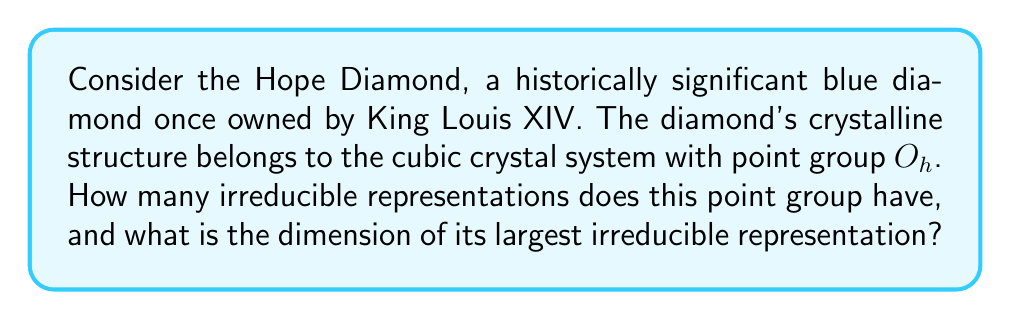Help me with this question. To solve this problem, we need to follow these steps:

1) First, recall that the point group $O_h$ is the full octahedral group, which is the symmetry group of a regular octahedron.

2) The order of the group $O_h$ is 48. This is because it contains 24 rotational symmetries and 24 rotoinversion symmetries.

3) For any finite group, the number of irreducible representations is equal to the number of conjugacy classes in the group. For $O_h$, there are 10 conjugacy classes.

4) To find the dimension of the largest irreducible representation, we can use the fact that the sum of the squares of the dimensions of all irreducible representations must equal the order of the group:

   $$\sum_{i=1}^{10} d_i^2 = 48$$

   where $d_i$ is the dimension of the $i$-th irreducible representation.

5) The dimensions of the irreducible representations of $O_h$ are:
   1, 1, 1, 1, 2, 2, 3, 3, 3, 3

6) We can verify:
   $$1^2 + 1^2 + 1^2 + 1^2 + 2^2 + 2^2 + 3^2 + 3^2 + 3^2 + 3^2 = 48$$

7) The largest dimension among these is 3.

Therefore, the point group $O_h$ has 10 irreducible representations, and the dimension of its largest irreducible representation is 3.
Answer: 10 irreducible representations; largest dimension is 3 